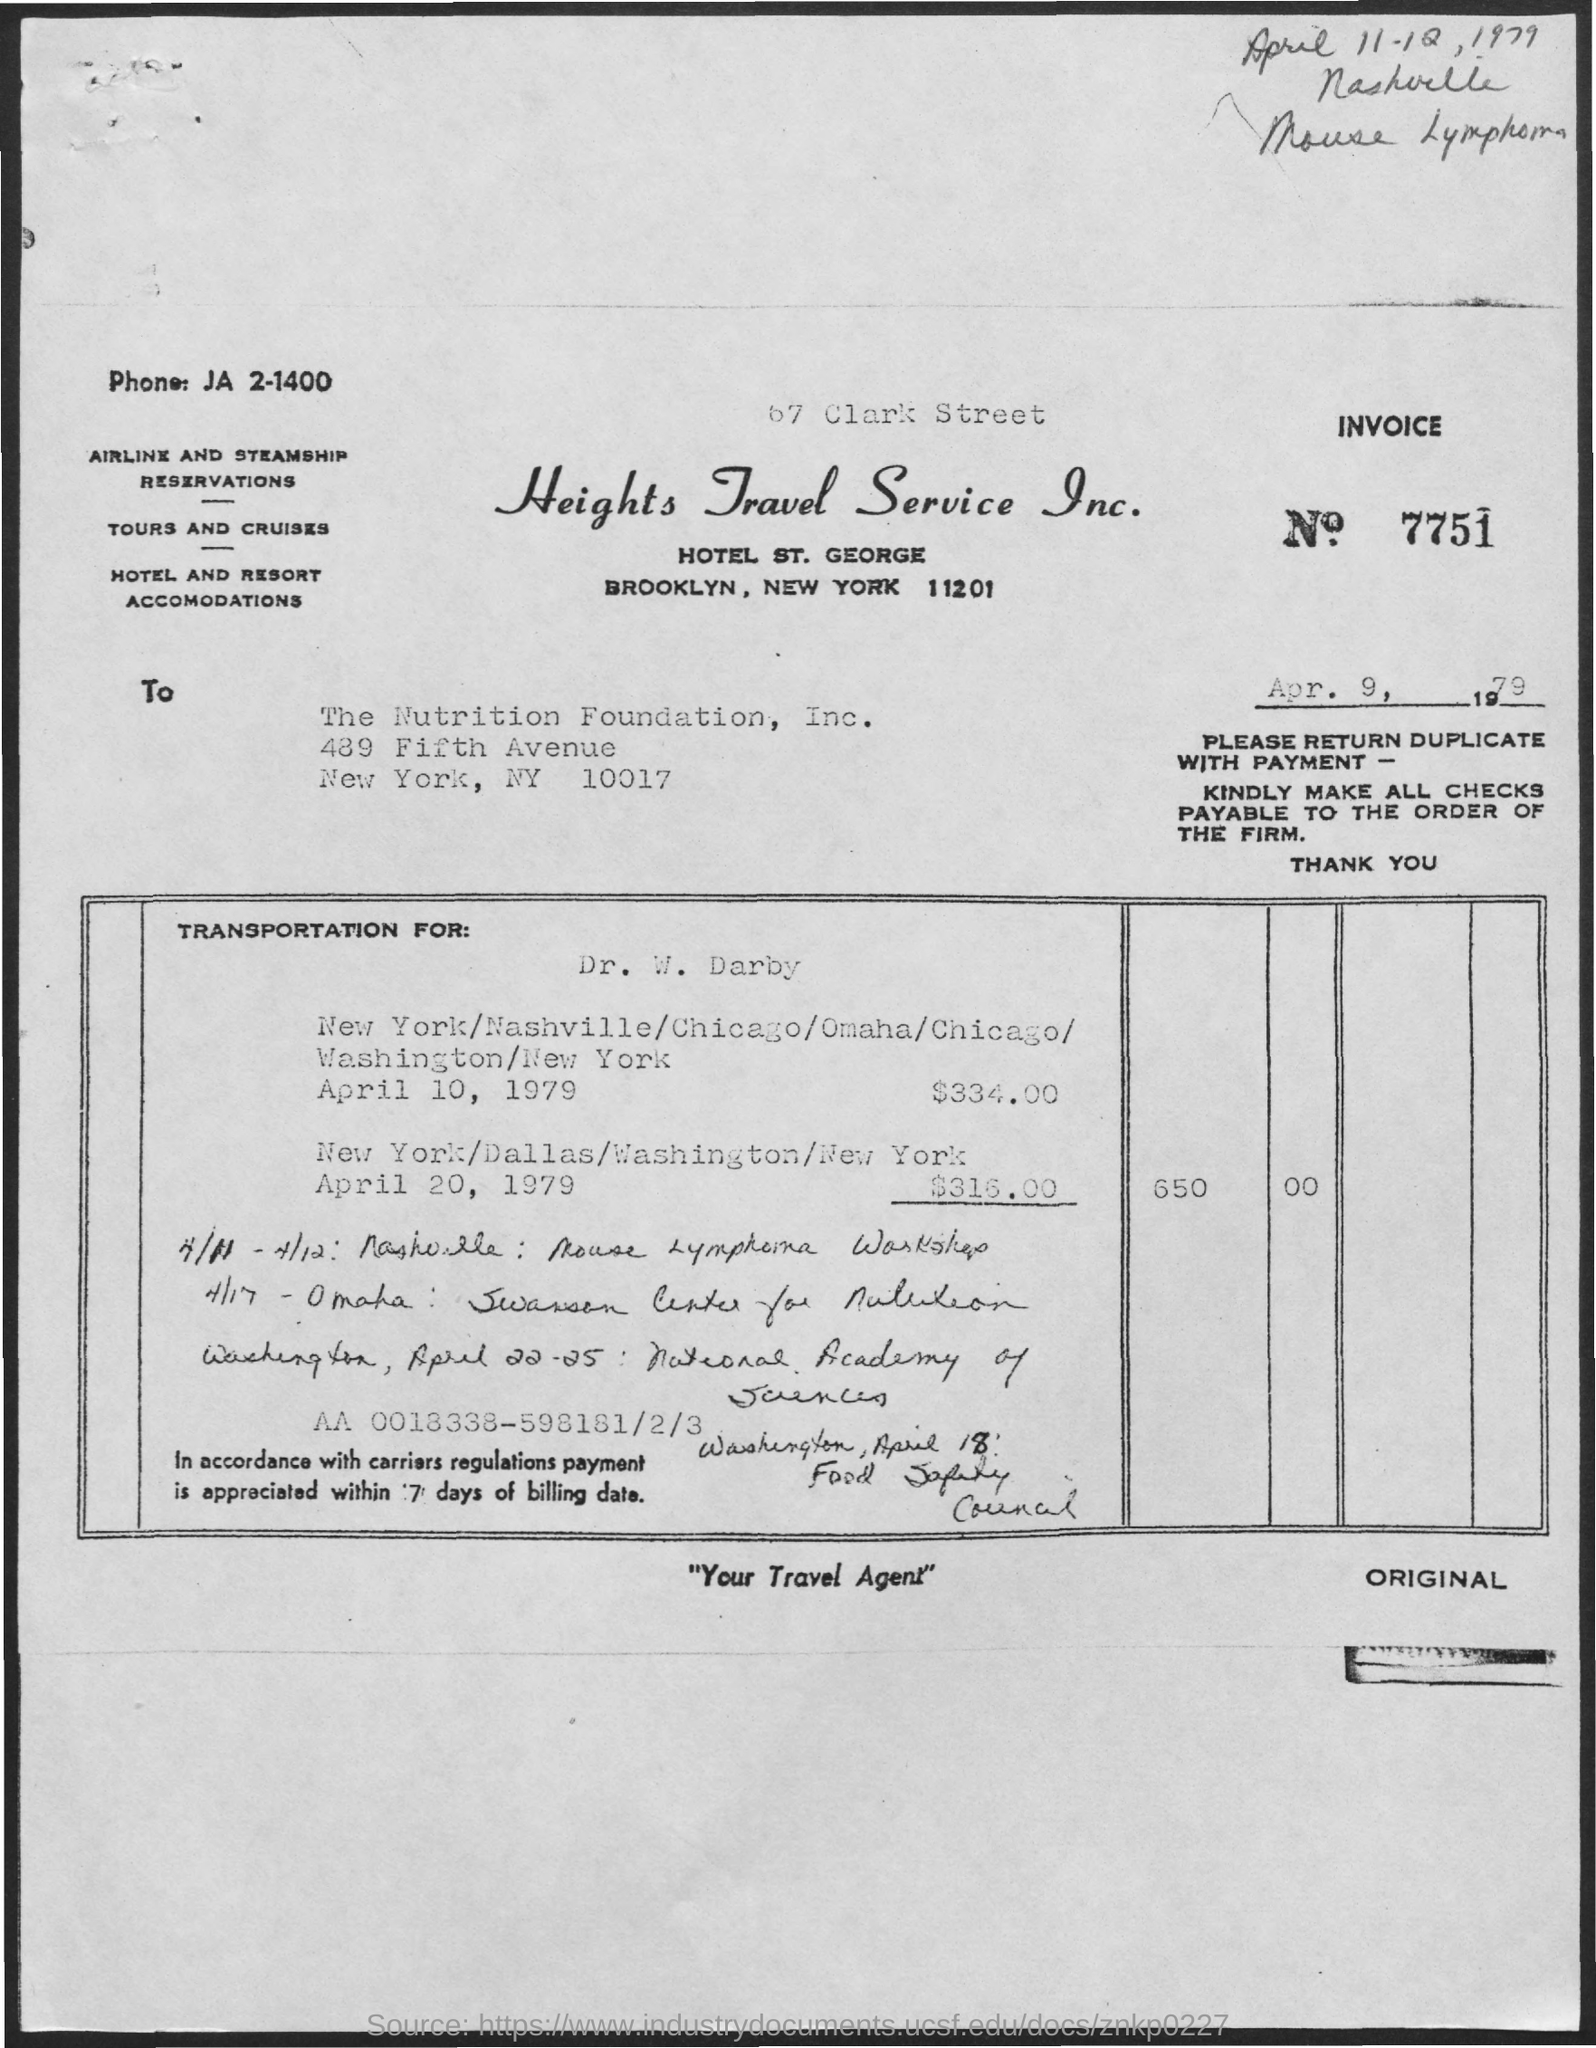Point out several critical features in this image. The invoice number is 7751. 